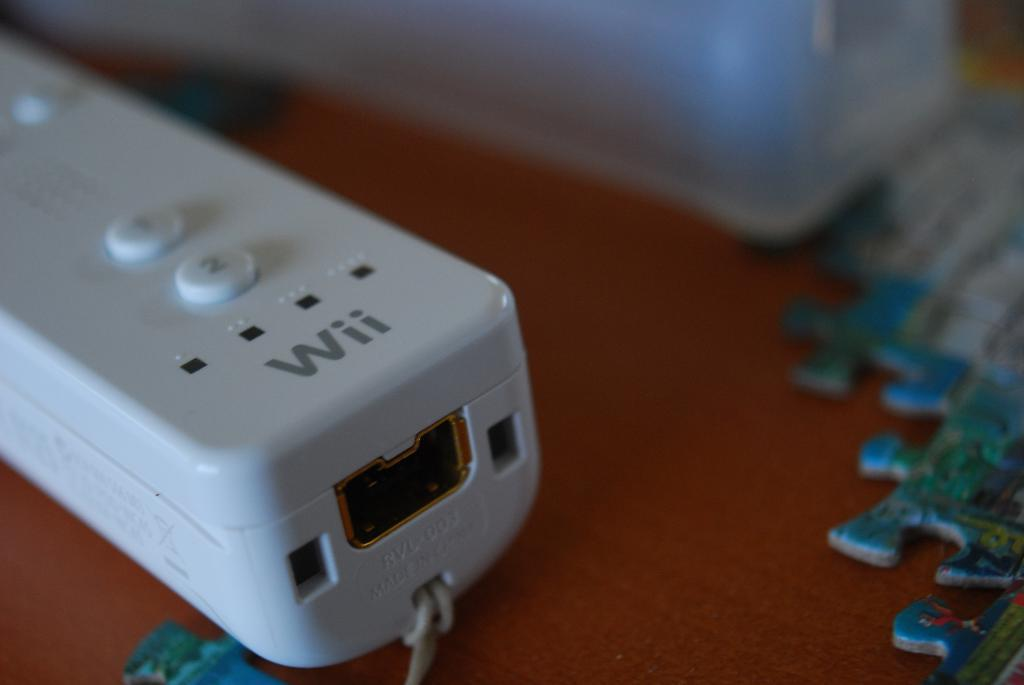What piece of furniture is present in the image? There is a table in the image. What is placed on the table? There is a white object and a jigsaw puzzle on the table. How many boats are visible in the image? There are no boats present in the image. What type of stocking is being worn by the person in the image? There is no person or stocking visible in the image. 